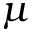<formula> <loc_0><loc_0><loc_500><loc_500>\mu</formula> 